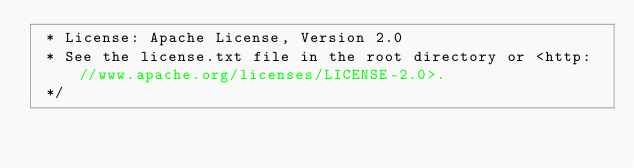<code> <loc_0><loc_0><loc_500><loc_500><_Java_> * License: Apache License, Version 2.0
 * See the license.txt file in the root directory or <http://www.apache.org/licenses/LICENSE-2.0>.
 */</code> 